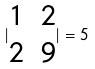Convert formula to latex. <formula><loc_0><loc_0><loc_500><loc_500>| \begin{matrix} 1 & 2 \\ 2 & 9 \\ \end{matrix} | = 5</formula> 